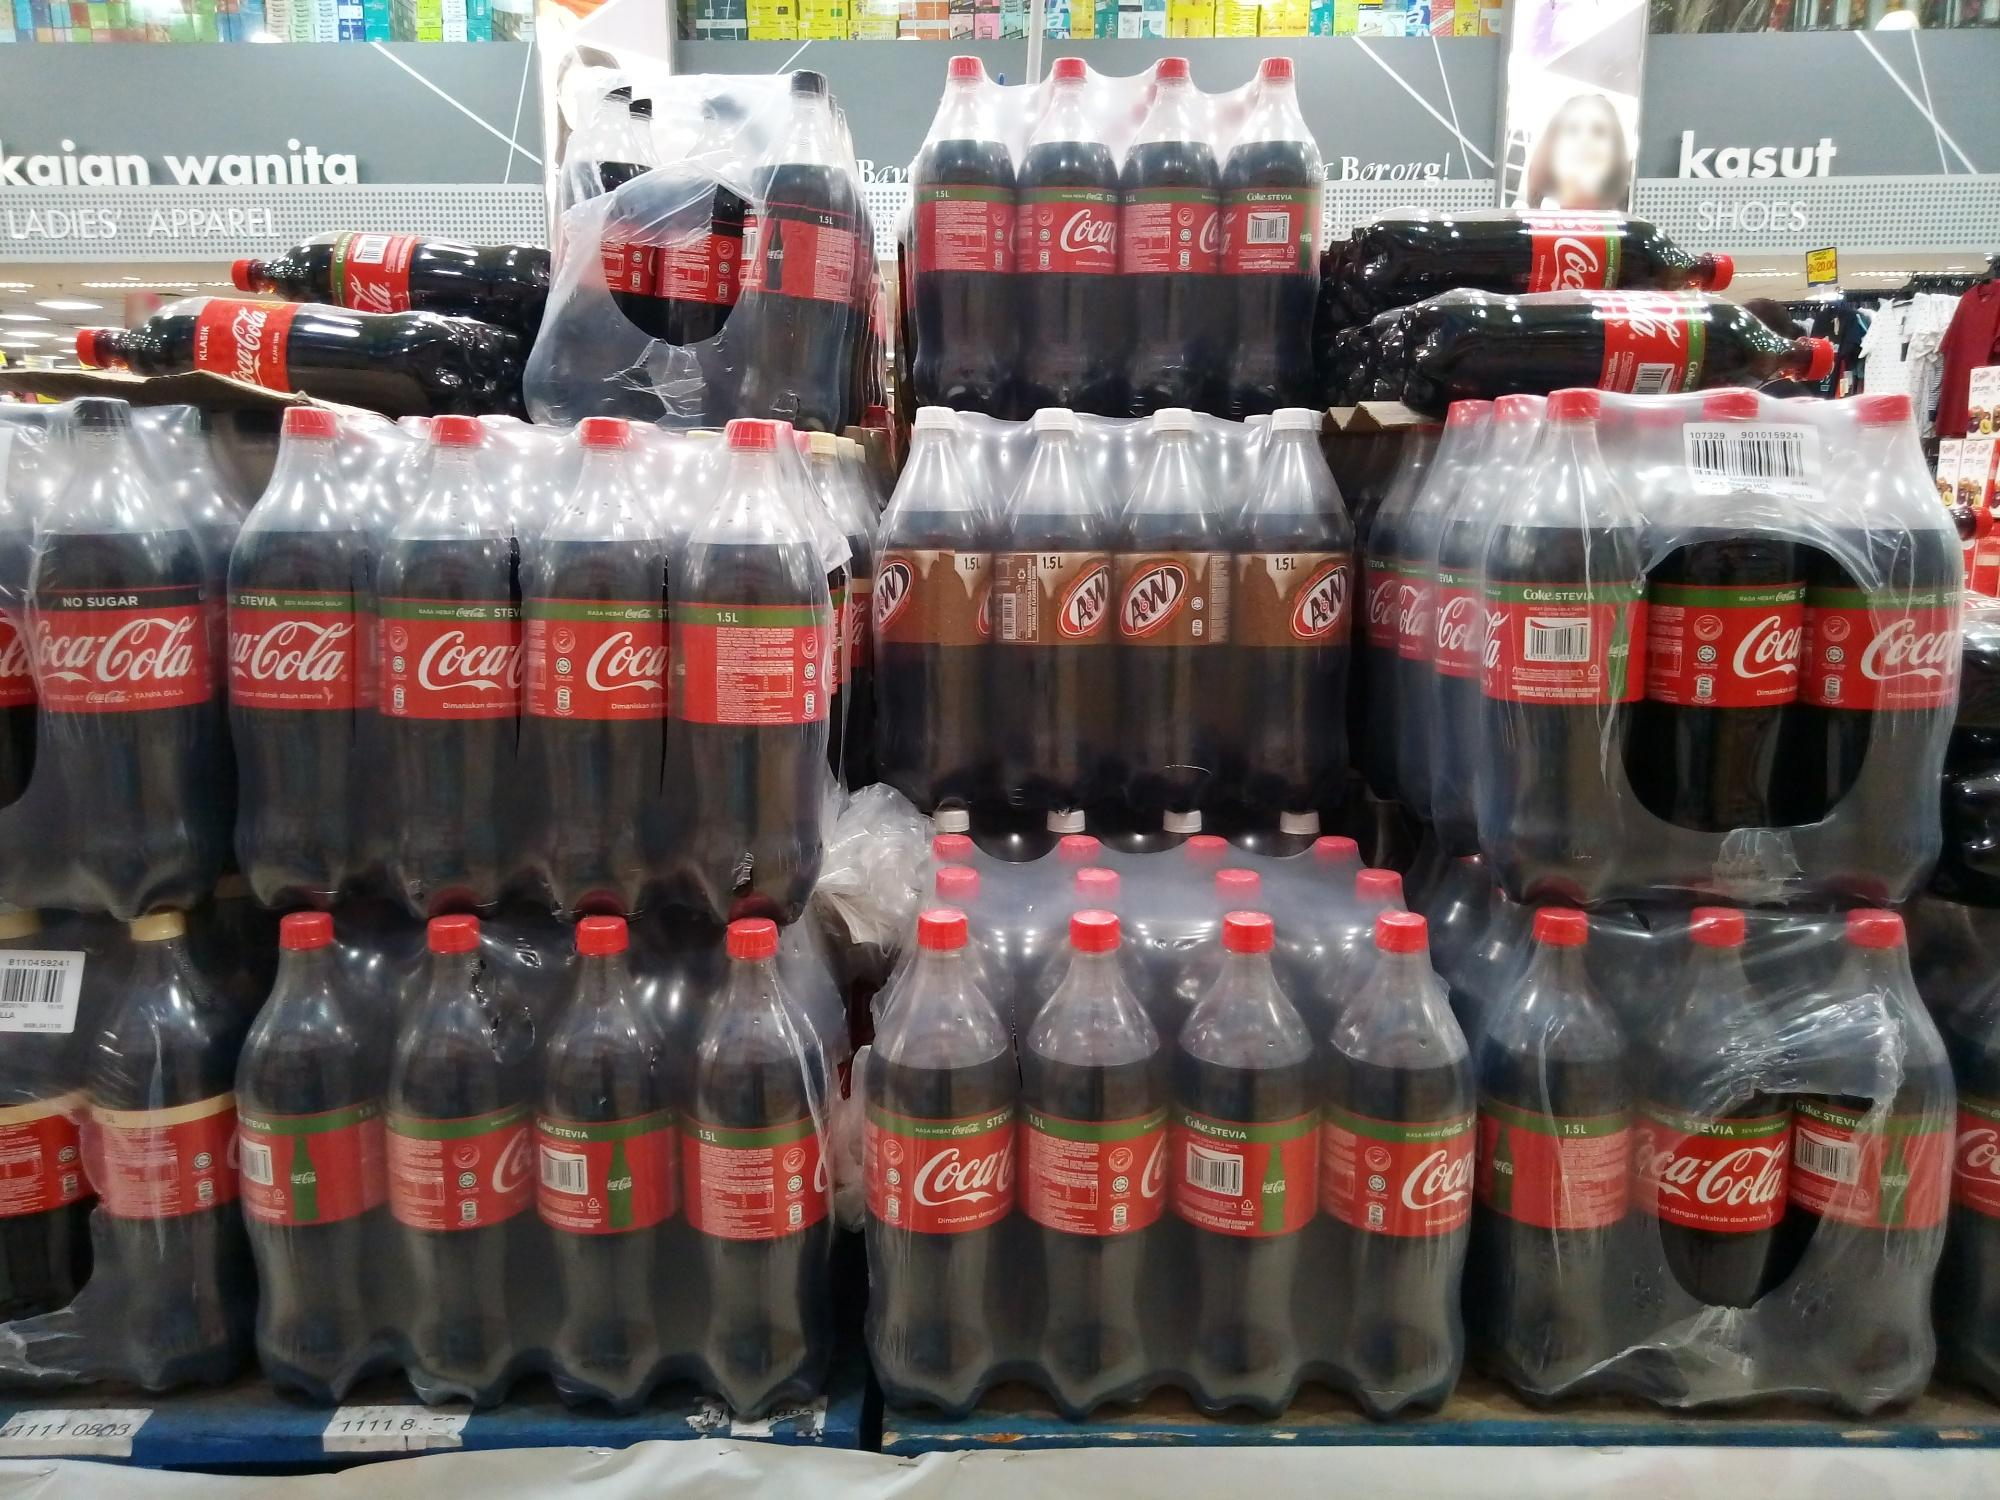Analyze the image in a comprehensive and detailed manner. The image features a retail store setting where a large display of Coca-Cola and A&W bottles is prominently showcased. The bottles are arranged in a pyramid-like structure, with larger 1.5L bottles forming the base and smaller bottles towards the top. Each Coca-Cola bottle, characterized by its dark brown content, red label, and red cap, is uniformly positioned to face forward, presenting a cohesive and neat appearance. Interspersed among the Coca-Cola bottles are a few A&W bottles sporting a similar design but with brown labels. The surrounding area suggests a well-organized retail environment with visible signs indicating 'Ladies Apparel' and 'Shoes.' This detailed arrangement and backdrop highlight a bustling and diverse retail atmosphere focused on attracting consumer attention through strategic product placement. 